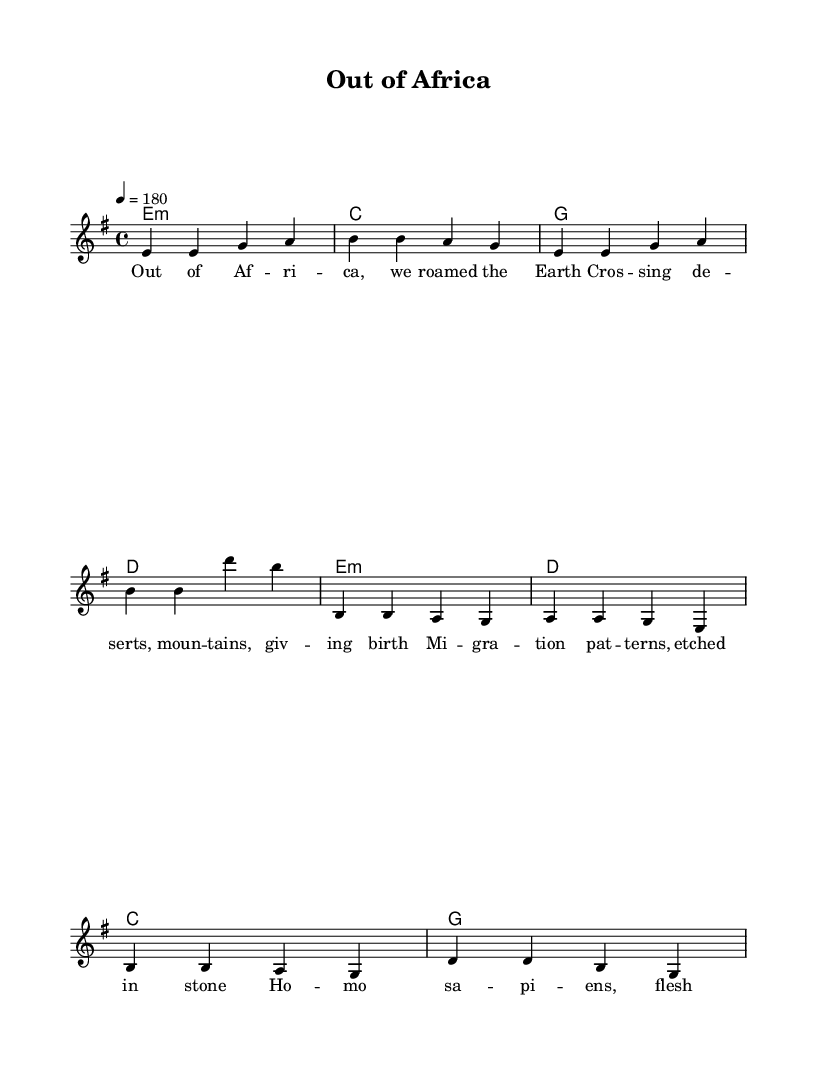What is the key signature of this music? The key signature is E minor, as indicated by the presence of one sharp (F#) in the key signature section of the music.
Answer: E minor What is the time signature of this piece? The time signature is 4/4, which means there are four beats per measure and the quarter note gets one beat, as shown at the beginning of the score.
Answer: 4/4 What is the tempo marking for this music? The tempo marking is 4 = 180, which indicates that the piece should be played at a speed of 180 beats per minute, noted in the tempo section.
Answer: 180 How many lines are in the melody staff? The melody staff consists of five lines, which is the standard for treble clef used in this sheet music for vocal melodies.
Answer: Five In the chorus, what are the first three notes of the melody? The first three notes in the chorus melody are B, B, A; these notes are directly written in the chorus melody section of the sheet music.
Answer: B, B, A What words follow "Migration patterns" in the chorus? The words that follow "Migration patterns" in the chorus are "etched in stone," as shown in the lyrics corresponding to the chorus melody.
Answer: etched in stone Which section contains the lyrics "Out of Africa"? The lyrics "Out of Africa" are found in the verse section of the sheet music, indicating the beginning line of the verses.
Answer: verse 